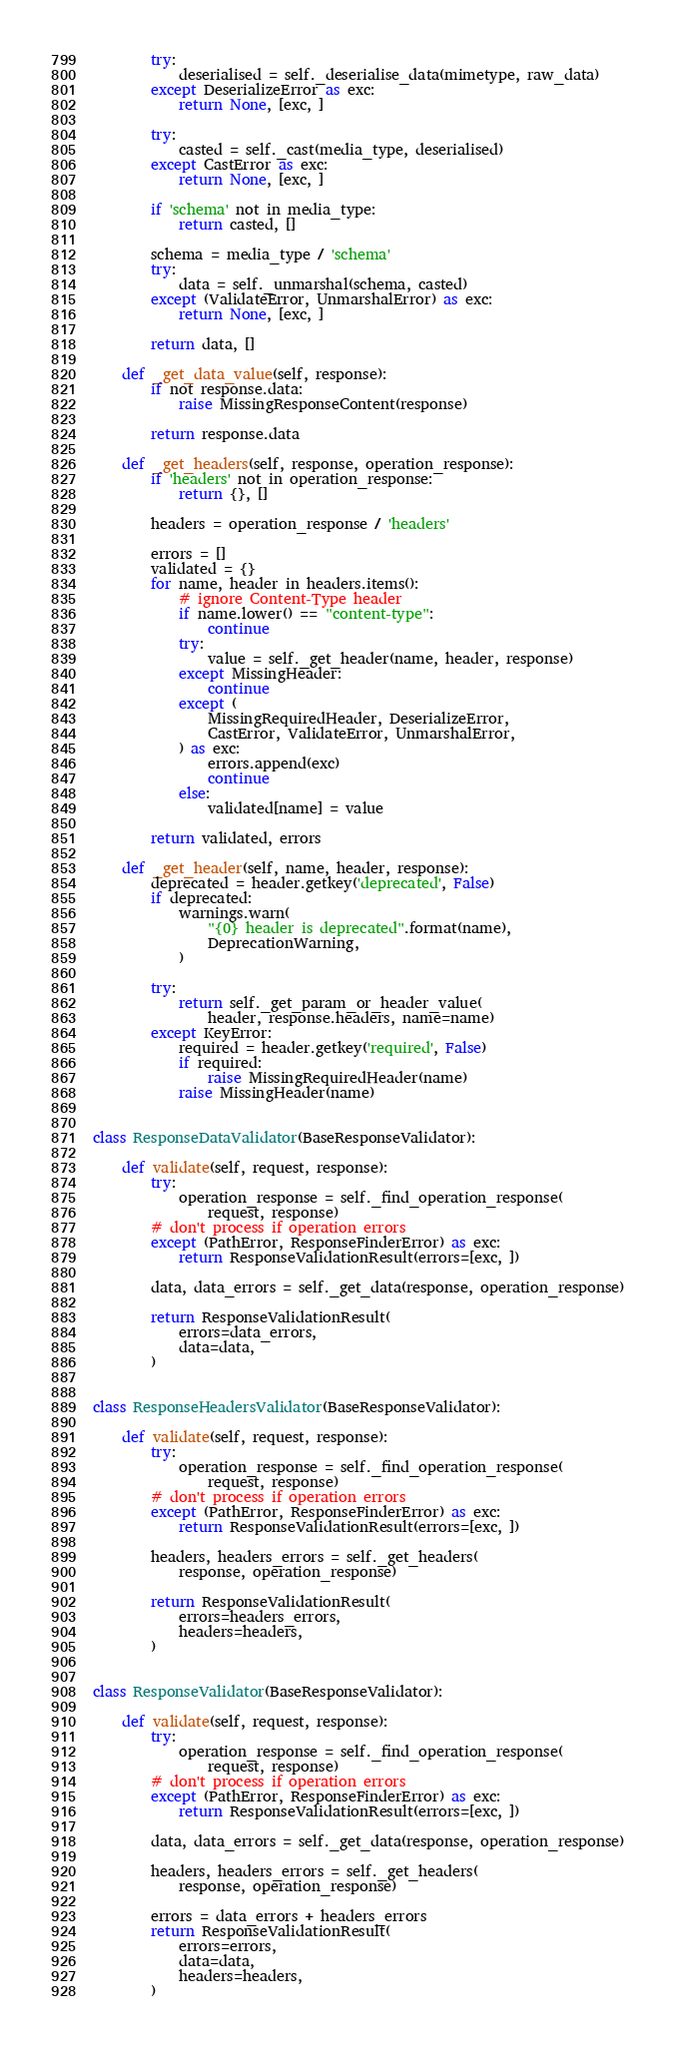<code> <loc_0><loc_0><loc_500><loc_500><_Python_>        try:
            deserialised = self._deserialise_data(mimetype, raw_data)
        except DeserializeError as exc:
            return None, [exc, ]

        try:
            casted = self._cast(media_type, deserialised)
        except CastError as exc:
            return None, [exc, ]

        if 'schema' not in media_type:
            return casted, []

        schema = media_type / 'schema'
        try:
            data = self._unmarshal(schema, casted)
        except (ValidateError, UnmarshalError) as exc:
            return None, [exc, ]

        return data, []

    def _get_data_value(self, response):
        if not response.data:
            raise MissingResponseContent(response)

        return response.data

    def _get_headers(self, response, operation_response):
        if 'headers' not in operation_response:
            return {}, []

        headers = operation_response / 'headers'

        errors = []
        validated = {}
        for name, header in headers.items():
            # ignore Content-Type header
            if name.lower() == "content-type":
                continue
            try:
                value = self._get_header(name, header, response)
            except MissingHeader:
                continue
            except (
                MissingRequiredHeader, DeserializeError,
                CastError, ValidateError, UnmarshalError,
            ) as exc:
                errors.append(exc)
                continue
            else:
                validated[name] = value

        return validated, errors

    def _get_header(self, name, header, response):
        deprecated = header.getkey('deprecated', False)
        if deprecated:
            warnings.warn(
                "{0} header is deprecated".format(name),
                DeprecationWarning,
            )

        try:
            return self._get_param_or_header_value(
                header, response.headers, name=name)
        except KeyError:
            required = header.getkey('required', False)
            if required:
                raise MissingRequiredHeader(name)
            raise MissingHeader(name)


class ResponseDataValidator(BaseResponseValidator):

    def validate(self, request, response):
        try:
            operation_response = self._find_operation_response(
                request, response)
        # don't process if operation errors
        except (PathError, ResponseFinderError) as exc:
            return ResponseValidationResult(errors=[exc, ])

        data, data_errors = self._get_data(response, operation_response)

        return ResponseValidationResult(
            errors=data_errors,
            data=data,
        )


class ResponseHeadersValidator(BaseResponseValidator):

    def validate(self, request, response):
        try:
            operation_response = self._find_operation_response(
                request, response)
        # don't process if operation errors
        except (PathError, ResponseFinderError) as exc:
            return ResponseValidationResult(errors=[exc, ])

        headers, headers_errors = self._get_headers(
            response, operation_response)

        return ResponseValidationResult(
            errors=headers_errors,
            headers=headers,
        )


class ResponseValidator(BaseResponseValidator):

    def validate(self, request, response):
        try:
            operation_response = self._find_operation_response(
                request, response)
        # don't process if operation errors
        except (PathError, ResponseFinderError) as exc:
            return ResponseValidationResult(errors=[exc, ])

        data, data_errors = self._get_data(response, operation_response)

        headers, headers_errors = self._get_headers(
            response, operation_response)

        errors = data_errors + headers_errors
        return ResponseValidationResult(
            errors=errors,
            data=data,
            headers=headers,
        )
</code> 